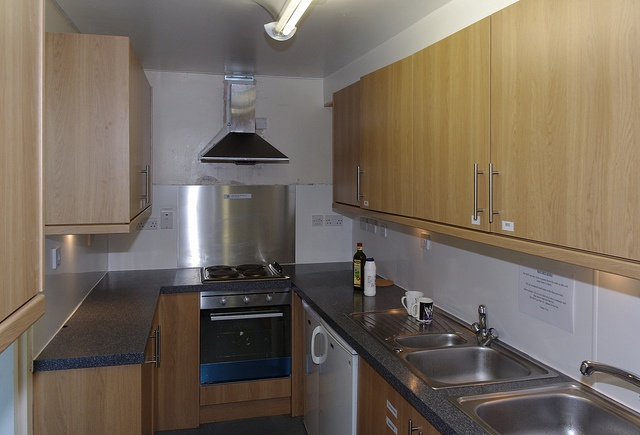Describe the objects in this image and their specific colors. I can see oven in tan, black, gray, and navy tones, sink in tan, gray, and black tones, refrigerator in tan, gray, and black tones, sink in tan, gray, and black tones, and sink in tan, black, gray, and maroon tones in this image. 